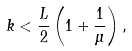Convert formula to latex. <formula><loc_0><loc_0><loc_500><loc_500>k < \frac { L } { 2 } \left ( 1 + \frac { 1 } { \mu } \right ) ,</formula> 